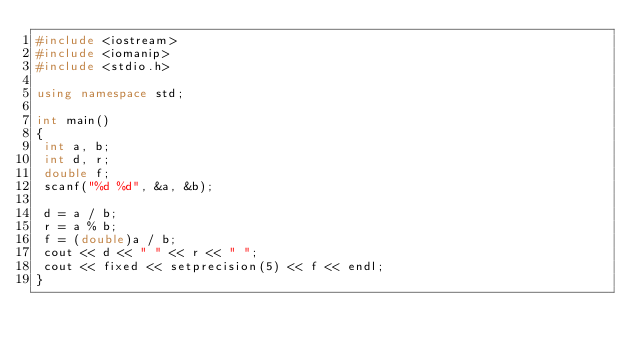<code> <loc_0><loc_0><loc_500><loc_500><_C++_>#include <iostream>
#include <iomanip>
#include <stdio.h>

using namespace std;

int main()
{
 int a, b;
 int d, r;
 double f;
 scanf("%d %d", &a, &b);

 d = a / b;
 r = a % b;
 f = (double)a / b;
 cout << d << " " << r << " ";
 cout << fixed << setprecision(5) << f << endl;
}
</code> 